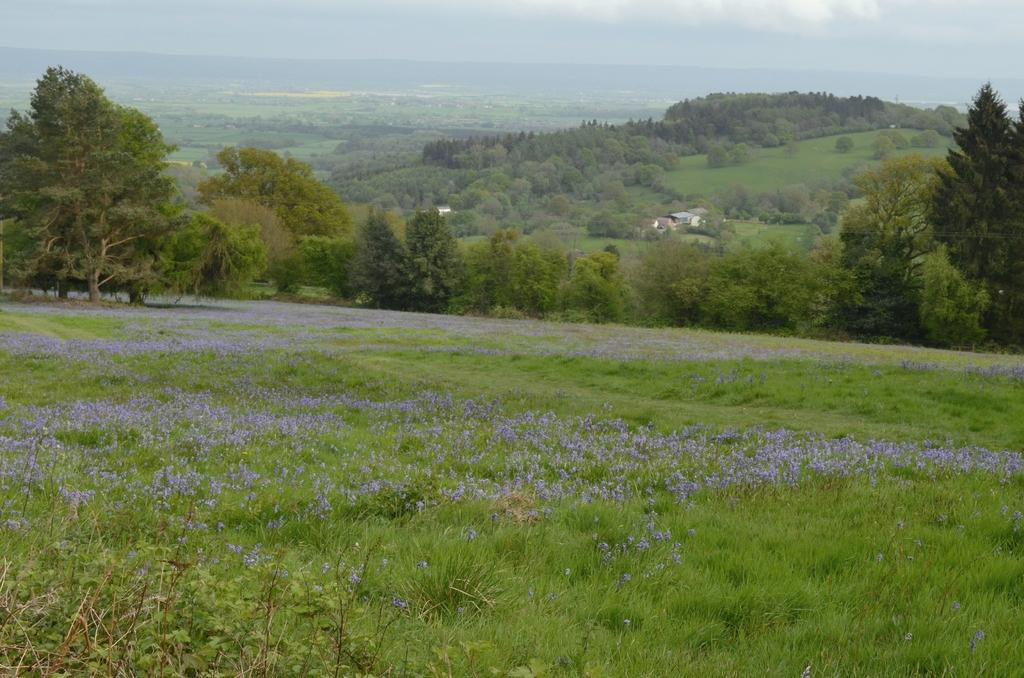What type of vegetation can be seen in the image? There is grass, plants, flowers, and trees in the image. What type of structures are visible in the image? There are houses in the image. What is visible in the background of the image? The sky is visible in the background of the image. What type of behavior can be observed in the fight between the organizations in the image? There is no fight or organizations present in the image; it features grass, plants, flowers, trees, and houses with a visible sky in the background. 